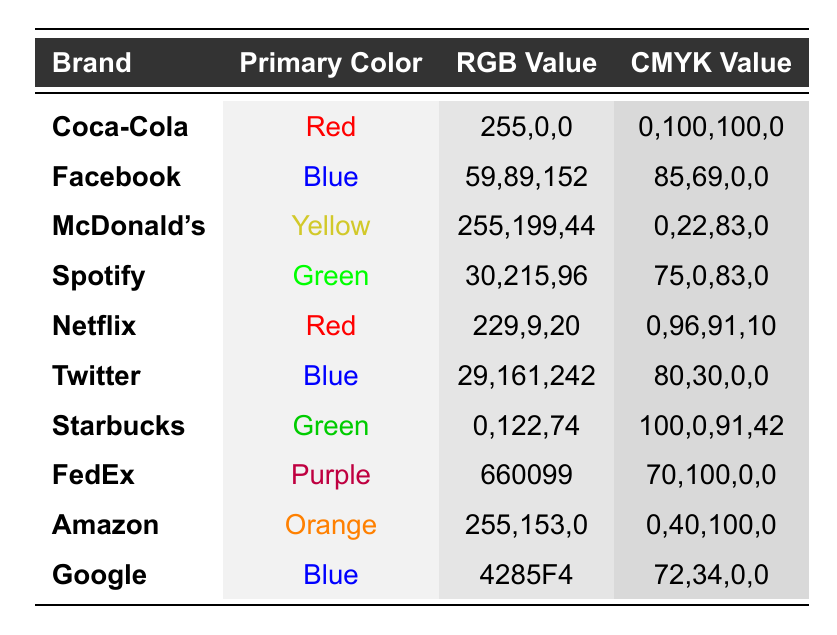What is the RGB value for Facebook's primary color? The table lists Facebook's primary color as Blue, and the corresponding RGB value is 59,89,152.
Answer: 59,89,152 Which brand has a primary color of Yellow? According to the table, McDonald's is the brand associated with the primary color Yellow.
Answer: McDonald's What are the CMYK values for Coca-Cola? Looking at the table, Coca-Cola has a CMYK value of 0,100,100,0.
Answer: 0,100,100,0 Is the primary color for both Twitter and Facebook the same? Twitter has a primary color of Blue, and Facebook also has a primary color of Blue, therefore they are the same.
Answer: Yes What is the primary color of Starbucks? The table shows that Starbucks' primary color is Green.
Answer: Green Which brand has the highest value in the first channel of their RGB value? Coca-Cola has an RGB value of 255,0,0, which has the highest value of 255 in the first channel compared to others.
Answer: Coca-Cola What is the average CMYK value of the brands with Red as the primary color? There are two brands with Red as the primary color (Coca-Cola: 0,100,100,0 and Netflix: 0,96,91,10). To average each CMYK component: for C (0+0)/2=0, for M (100+96)/2=98, for Y (100+91)/2=95.5 (rounded to 96), for K (0+10)/2=5. Therefore, the average is 0,98,96,5.
Answer: 0,98,96,5 Which brand has the RGB value closest to 0 in the first channel? Starbucks has an RGB value of 0,122,74, which is the closest to 0 in the first channel compared to others.
Answer: Starbucks How many brands have Green as their primary color? From the table, there are two brands with Green as their primary color: Spotify and Starbucks.
Answer: 2 Is the CMYK value for Amazon equal to the CMYK value for FedEx? Amazon's CMYK value is 0,40,100,0 and FedEx's CMYK value is 70,100,0, which are not equal.
Answer: No What is the difference in the first channel's RGB values of Spotify and McDonald's? Spotify has an RGB value of 30,215,96 and McDonald's has 255,199,44. The difference in the first channel is 255 - 30 = 225.
Answer: 225 